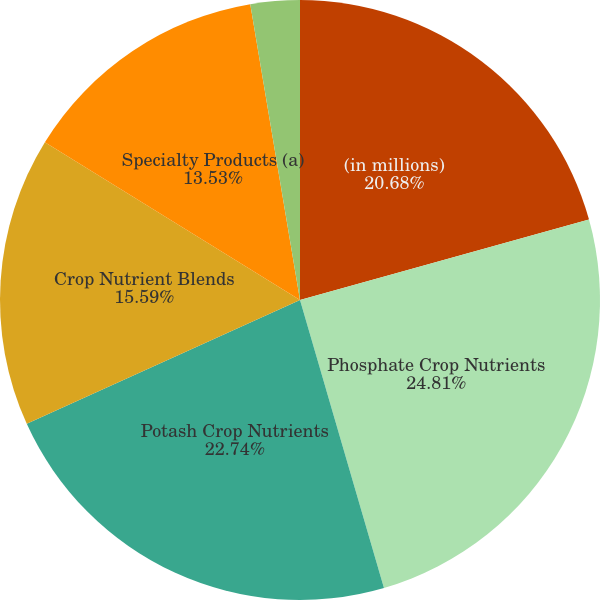<chart> <loc_0><loc_0><loc_500><loc_500><pie_chart><fcel>(in millions)<fcel>Phosphate Crop Nutrients<fcel>Potash Crop Nutrients<fcel>Crop Nutrient Blends<fcel>Specialty Products (a)<fcel>Other (b)<nl><fcel>20.68%<fcel>24.8%<fcel>22.74%<fcel>15.59%<fcel>13.53%<fcel>2.65%<nl></chart> 